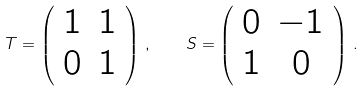Convert formula to latex. <formula><loc_0><loc_0><loc_500><loc_500>T = \left ( \begin{array} { c c } 1 & 1 \\ 0 & 1 \end{array} \right ) \, , \quad S = \left ( \begin{array} { c c } 0 & - 1 \\ 1 & 0 \end{array} \right ) \, .</formula> 